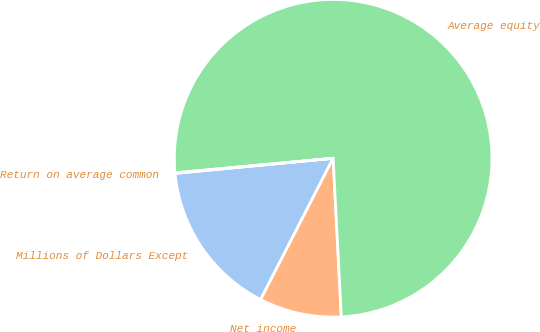<chart> <loc_0><loc_0><loc_500><loc_500><pie_chart><fcel>Millions of Dollars Except<fcel>Net income<fcel>Average equity<fcel>Return on average common<nl><fcel>15.93%<fcel>8.37%<fcel>75.64%<fcel>0.06%<nl></chart> 